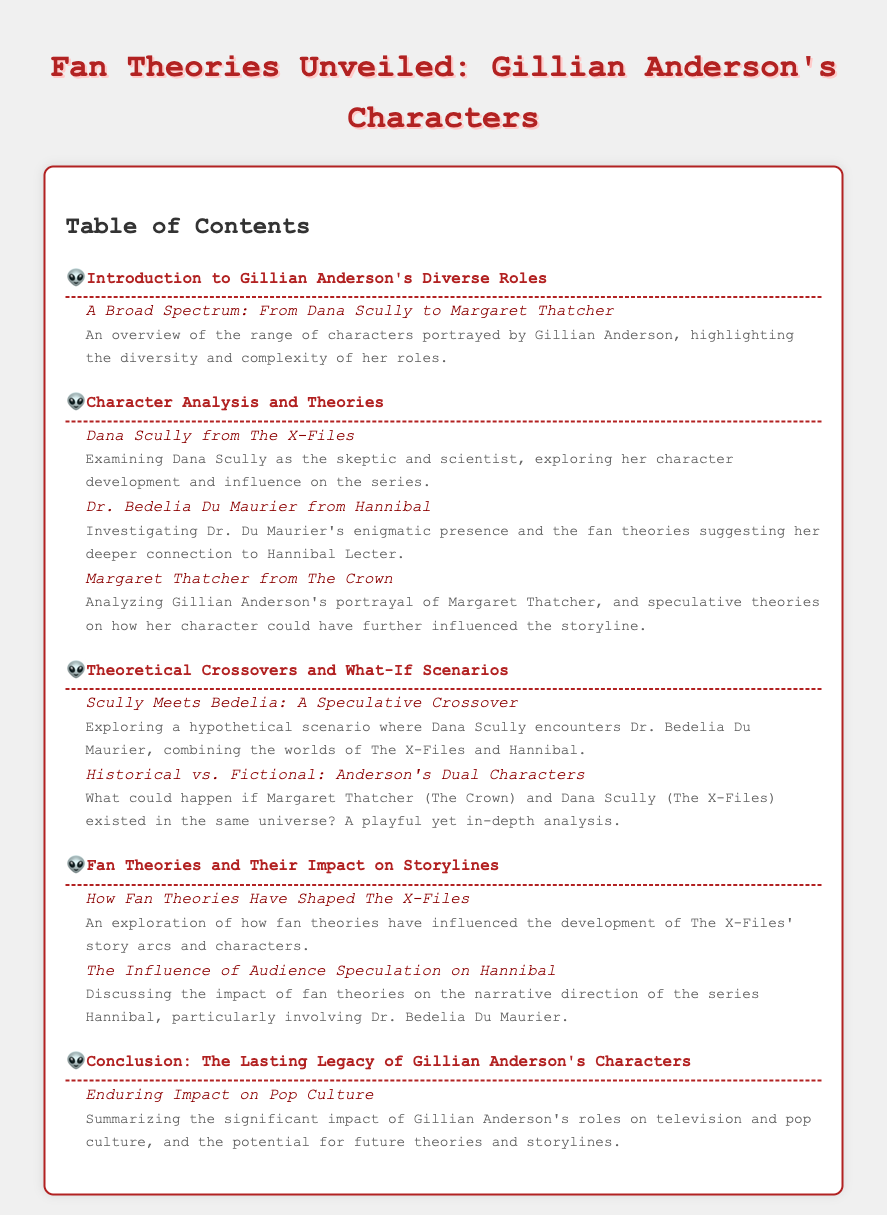what is the title of the document? The title is prominently displayed at the top of the document, indicating the overall theme.
Answer: Fan Theories Unveiled: Gillian Anderson's Characters how many main sections are there in the Table of Contents? The sections are clearly numbered and listed, providing a quick overview of the document's structure.
Answer: 5 who is the character analyzed from The X-Files? The character mentioned in the character analysis section represents a critical part of Gillian Anderson's work.
Answer: Dana Scully what character does Gillian Anderson portray in The Crown? The document specifies one of Gillian Anderson's iconic characters, particularly in the context of historical significance.
Answer: Margaret Thatcher what is one hypothetical scenario explored in the document? The document presents a creative approach combining multiple character universes, indicating a fun speculative analysis.
Answer: Scully Meets Bedelia which character is investigated for their connection to Hannibal Lecter? The description indicates the character's mysterious ties within the narrative structure of the series.
Answer: Dr. Bedelia Du Maurier what is discussed in relation to fan theories and The X-Files? The influence of audience speculation is examined to understand how it shapes the storyline and character arcs.
Answer: How Fan Theories Have Shaped The X-Files what is the concluding section about? The conclusion encapsulates the prevalent themes introduced throughout the document and addresses overall impact.
Answer: The Lasting Legacy of Gillian Anderson's Characters 